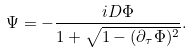Convert formula to latex. <formula><loc_0><loc_0><loc_500><loc_500>\Psi = - { \frac { i D \Phi } { 1 + \sqrt { 1 - ( \partial _ { \tau } \Phi ) ^ { 2 } } } } .</formula> 